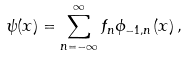<formula> <loc_0><loc_0><loc_500><loc_500>\psi ( x ) = \sum _ { n = - \infty } ^ { \infty } f _ { n } \phi _ { - 1 , n } ( x ) \, ,</formula> 